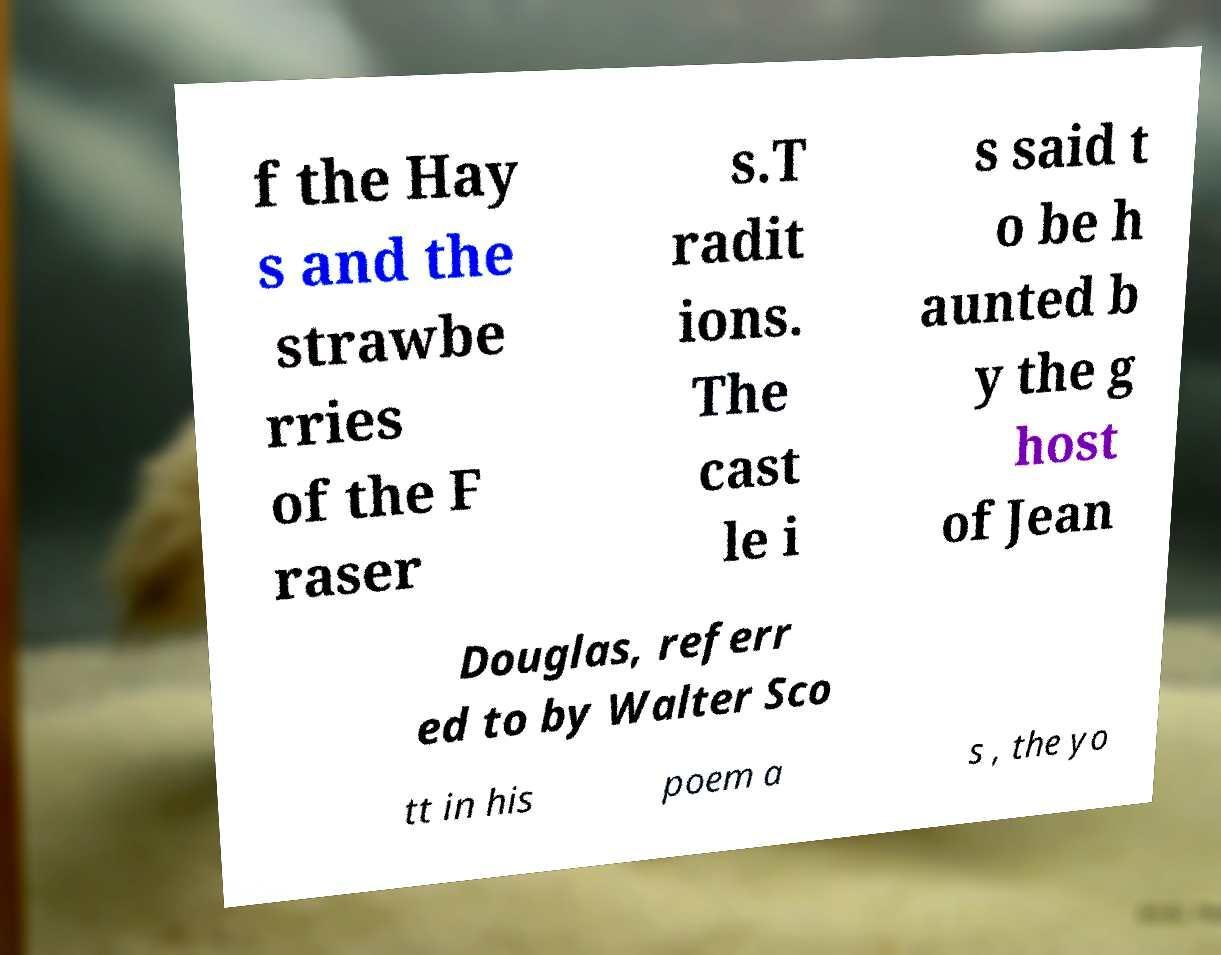What messages or text are displayed in this image? I need them in a readable, typed format. f the Hay s and the strawbe rries of the F raser s.T radit ions. The cast le i s said t o be h aunted b y the g host of Jean Douglas, referr ed to by Walter Sco tt in his poem a s , the yo 